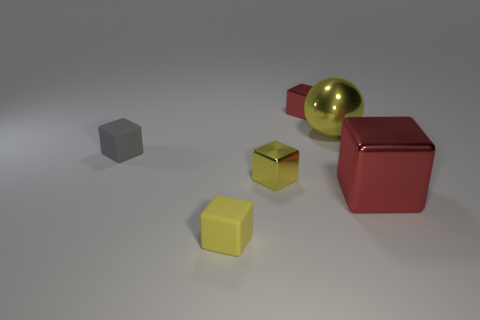Subtract all gray cubes. How many cubes are left? 4 Subtract all large metal blocks. How many blocks are left? 4 Subtract all gray blocks. Subtract all gray spheres. How many blocks are left? 4 Add 3 tiny red blocks. How many objects exist? 9 Subtract all balls. How many objects are left? 5 Subtract 0 brown cubes. How many objects are left? 6 Subtract all tiny matte objects. Subtract all rubber cubes. How many objects are left? 2 Add 4 red cubes. How many red cubes are left? 6 Add 5 gray shiny spheres. How many gray shiny spheres exist? 5 